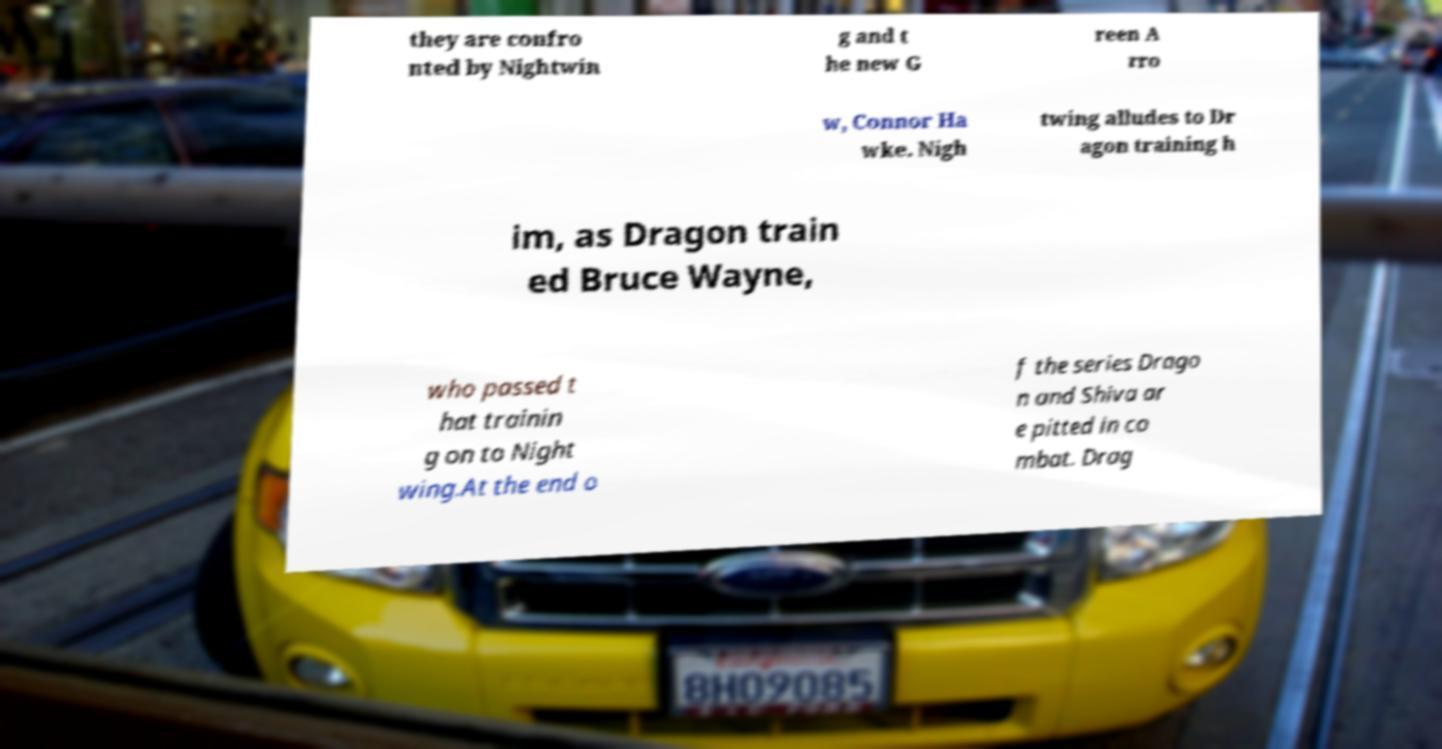Could you extract and type out the text from this image? they are confro nted by Nightwin g and t he new G reen A rro w, Connor Ha wke. Nigh twing alludes to Dr agon training h im, as Dragon train ed Bruce Wayne, who passed t hat trainin g on to Night wing.At the end o f the series Drago n and Shiva ar e pitted in co mbat. Drag 